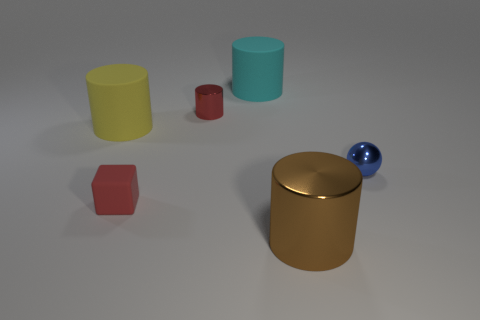Subtract all tiny metal cylinders. How many cylinders are left? 3 Add 4 tiny yellow shiny objects. How many objects exist? 10 Subtract all cyan cylinders. How many cylinders are left? 3 Subtract 1 cylinders. How many cylinders are left? 3 Subtract all spheres. How many objects are left? 5 Subtract all red cylinders. Subtract all blue spheres. How many cylinders are left? 3 Subtract all tiny blue objects. Subtract all small cyan cubes. How many objects are left? 5 Add 4 small red cylinders. How many small red cylinders are left? 5 Add 5 tiny gray metal blocks. How many tiny gray metal blocks exist? 5 Subtract 1 blue balls. How many objects are left? 5 